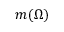<formula> <loc_0><loc_0><loc_500><loc_500>m ( \Omega )</formula> 